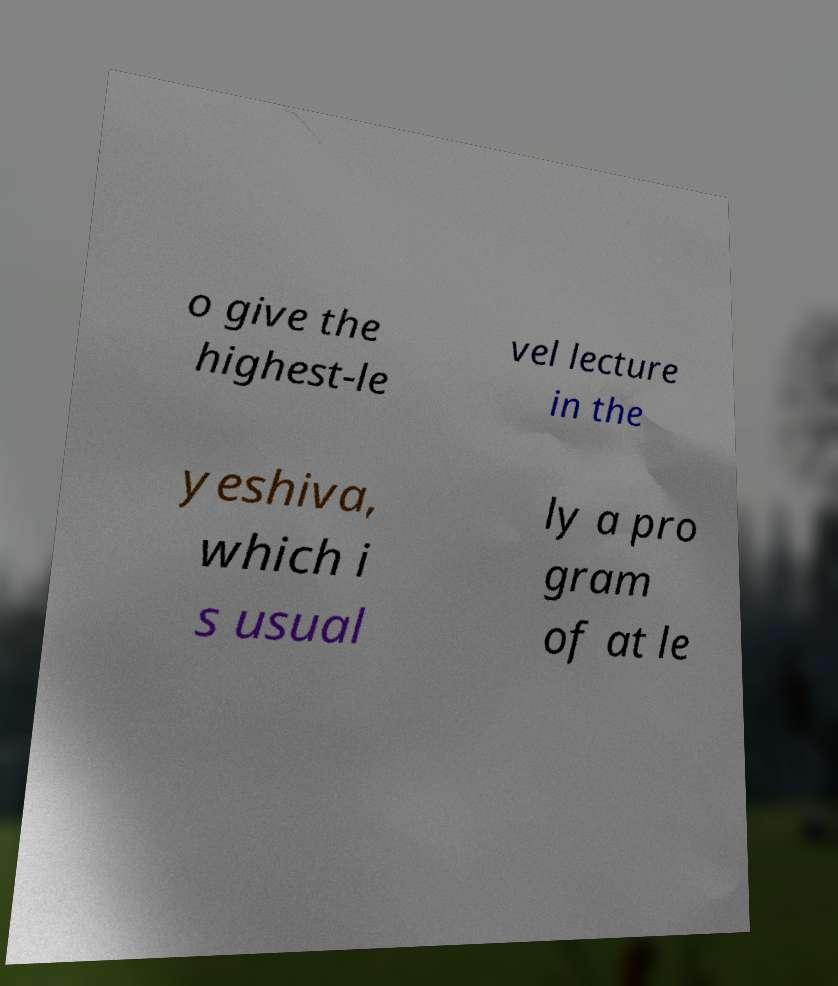Please read and relay the text visible in this image. What does it say? o give the highest-le vel lecture in the yeshiva, which i s usual ly a pro gram of at le 